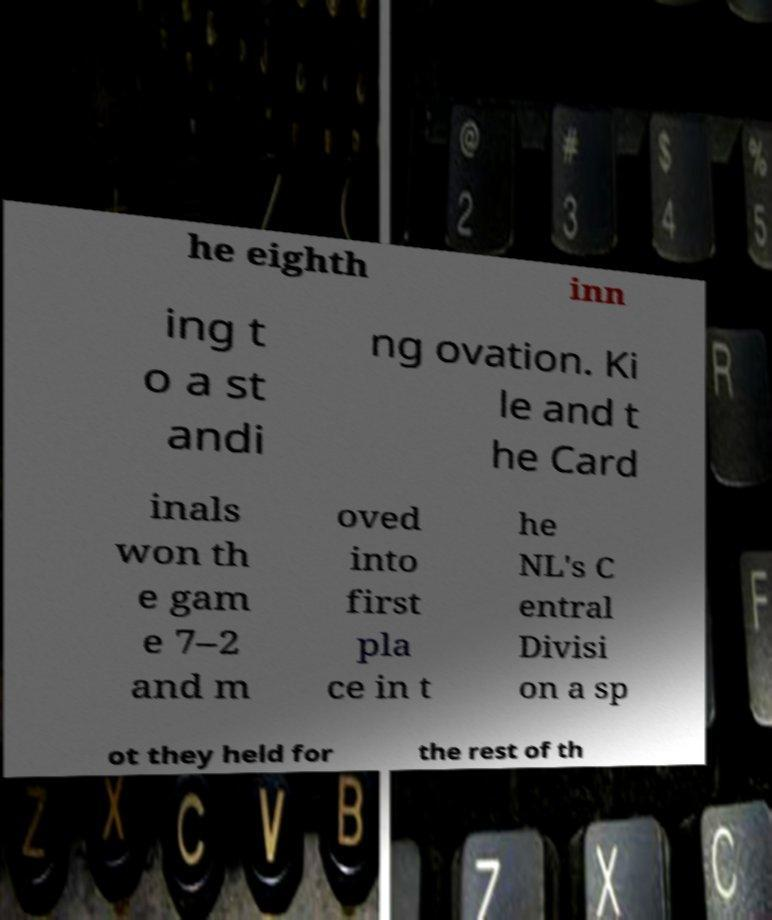Can you read and provide the text displayed in the image?This photo seems to have some interesting text. Can you extract and type it out for me? he eighth inn ing t o a st andi ng ovation. Ki le and t he Card inals won th e gam e 7–2 and m oved into first pla ce in t he NL's C entral Divisi on a sp ot they held for the rest of th 